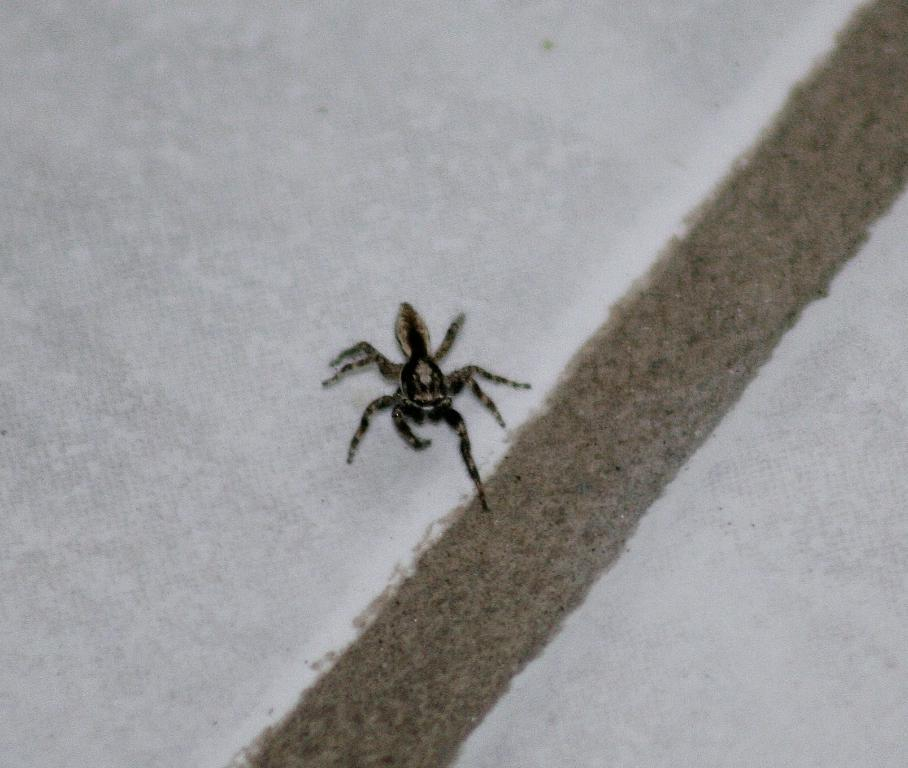What is the main subject of the image? The main subject of the image is a spider. Where is the spider located in the image? The spider is on a wall. Can you describe the position of the spider in the image? The spider is located in the middle of the image. What color is the daughter's cap in the image? There is no daughter or cap present in the image; it only features a spider on a wall. 